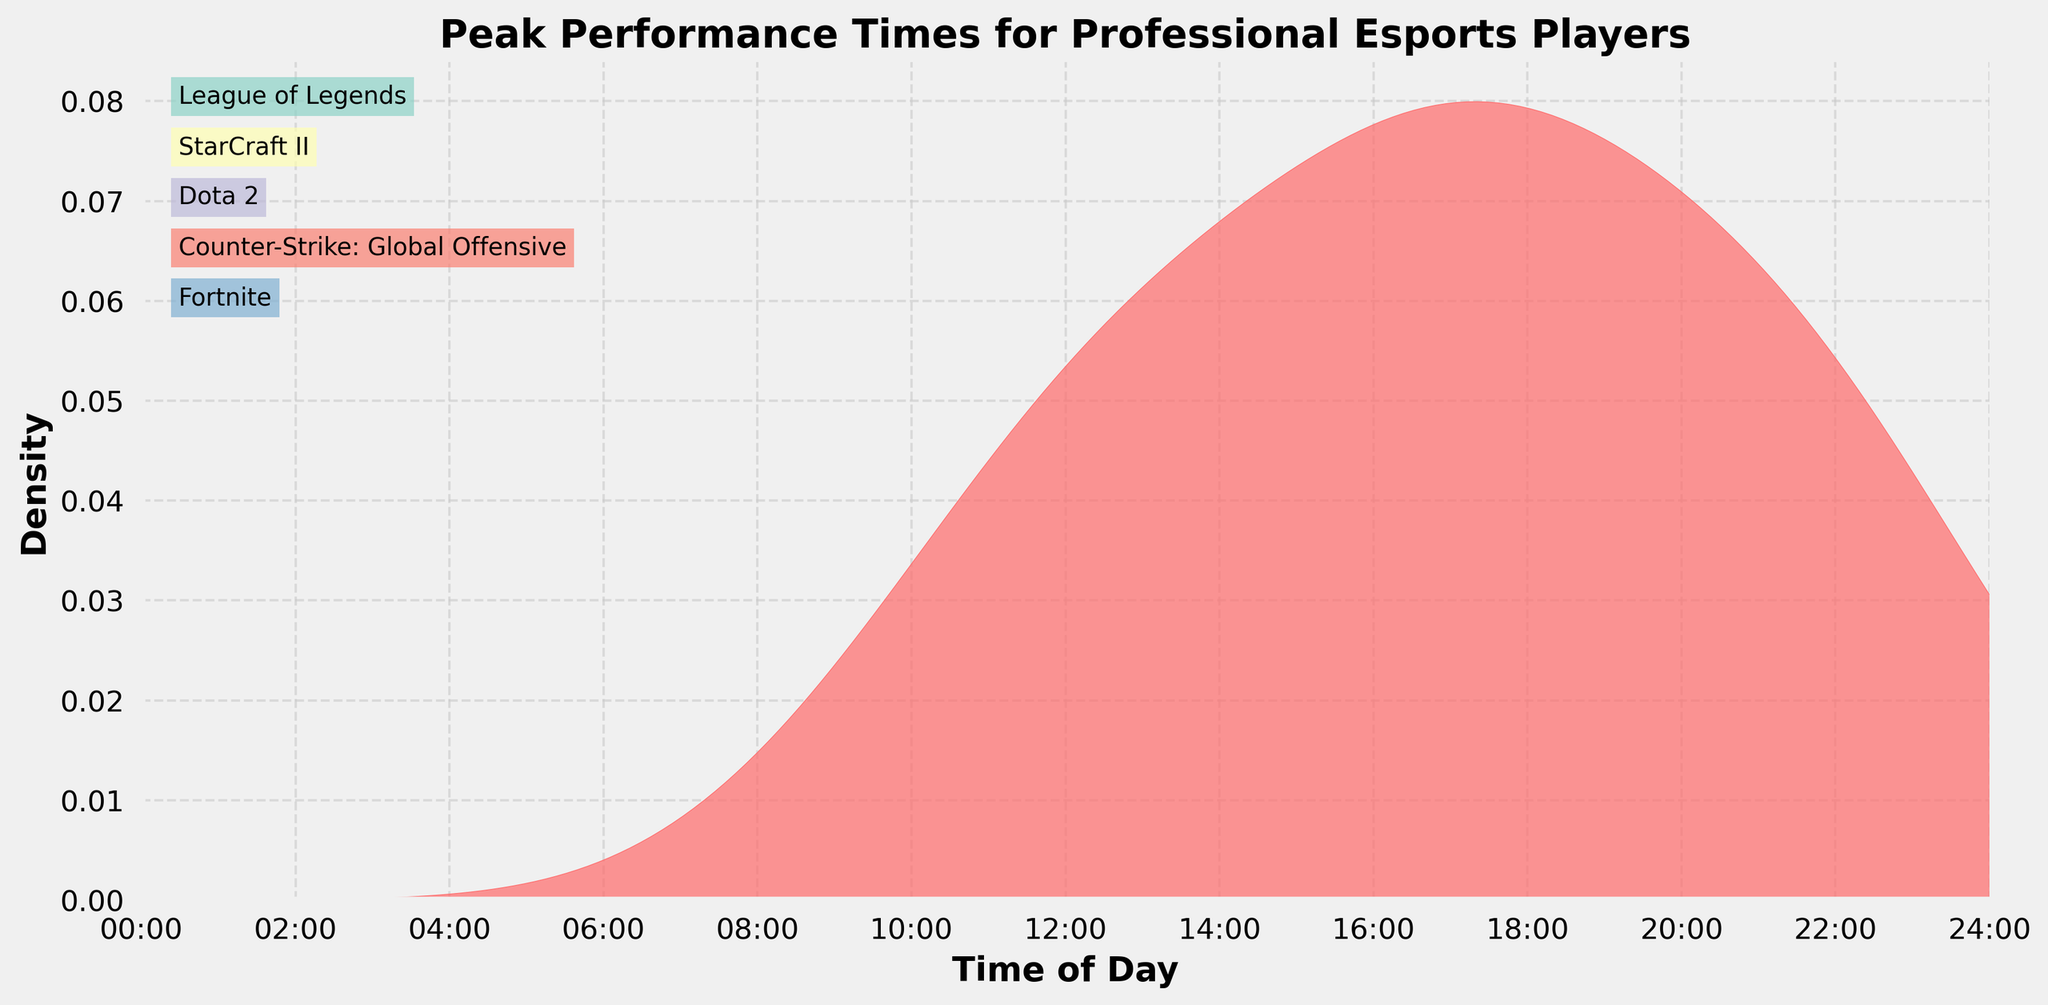What is the title of the plot? The title of the plot is usually located at the top of the figure and is presented in a bold and larger font size.
Answer: Peak Performance Times for Professional Esports Players What does the x-axis represent in this figure? The x-axis represents the time of day, and this can be inferred from the labels and units shown along the axis.
Answer: Time of Day What is the density function's peak time for the esports players? This can be determined by looking for the highest point in the density plot, which indicates the time of day when most players reach their peak performance.
Answer: Around 16:00 What are the unique games included in the plot? The games are mentioned in annotations on the plot; to identify them, one can look at the labeled annotations on the right-hand side of the plot.
Answer: League of Legends, StarCraft II, Dota 2, Counter-Strike: Global Offensive, and Fortnite At what times do the players have the lowest density of peak performance? The lowest density values can be identified at the dips in the density plot. These dips indicate times of day with the least number of players at their peak performance.
Answer: Around 09:00 and 23:00 Which time of day shows a higher density of peak performance: 12:00 or 18:00? By comparing the height of the density plot at 12:00 and 18:00, the time with a higher density peak can be determined.
Answer: 18:00 Is the peak performance more concentrated in the morning or afternoon? To answer this, compare the density values from the morning (before noon) to the afternoon (after noon) by assessing the relative heights of the density plot.
Answer: Afternoon How does the density of peak performance times vary between 20:00 and 22:00? Observing the gradient and the height of the density plot between these times can provide insights into how the peak performance density changes.
Answer: Increases and then decreases What time segment has the widest range of high-density values? By examining the plot for the broadest span where the density remains high, determine the time range with sustained high density.
Answer: Between 14:00 and 18:00 What could be a possible reason for low density peaks in early morning hours? Consider potential reasons outside the plot, such as typical sleeping patterns and natural circadian rhythms that could affect early morning peak performances.
Answer: Players are likely not performing at their peak due to typical sleep schedules 